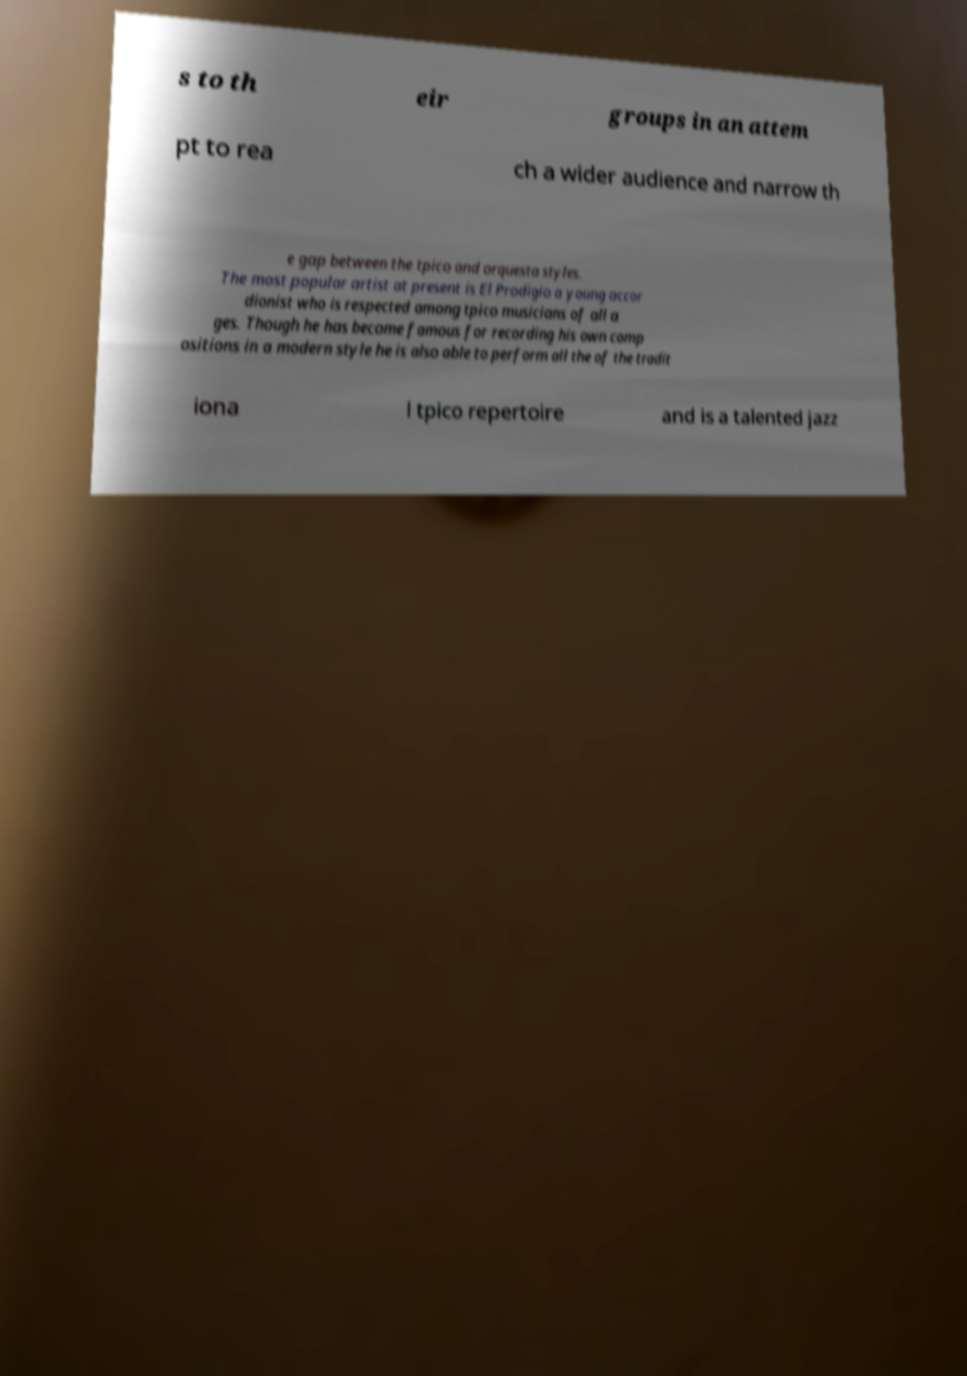Please identify and transcribe the text found in this image. s to th eir groups in an attem pt to rea ch a wider audience and narrow th e gap between the tpico and orquesta styles. The most popular artist at present is El Prodigio a young accor dionist who is respected among tpico musicians of all a ges. Though he has become famous for recording his own comp ositions in a modern style he is also able to perform all the of the tradit iona l tpico repertoire and is a talented jazz 